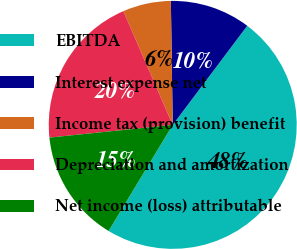<chart> <loc_0><loc_0><loc_500><loc_500><pie_chart><fcel>EBITDA<fcel>Interest expense net<fcel>Income tax (provision) benefit<fcel>Depreciation and amortization<fcel>Net income (loss) attributable<nl><fcel>48.39%<fcel>10.5%<fcel>6.28%<fcel>20.12%<fcel>14.71%<nl></chart> 